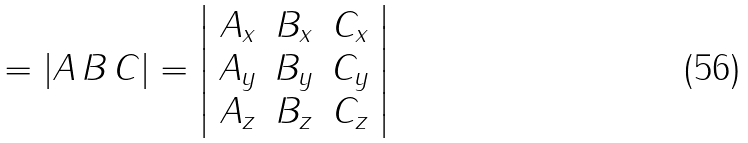Convert formula to latex. <formula><loc_0><loc_0><loc_500><loc_500>= | A \, B \, C | = \left | { \begin{array} { c c c } { A _ { x } } & { B _ { x } } & { C _ { x } } \\ { A _ { y } } & { B _ { y } } & { C _ { y } } \\ { A _ { z } } & { B _ { z } } & { C _ { z } } \end{array} } \right |</formula> 